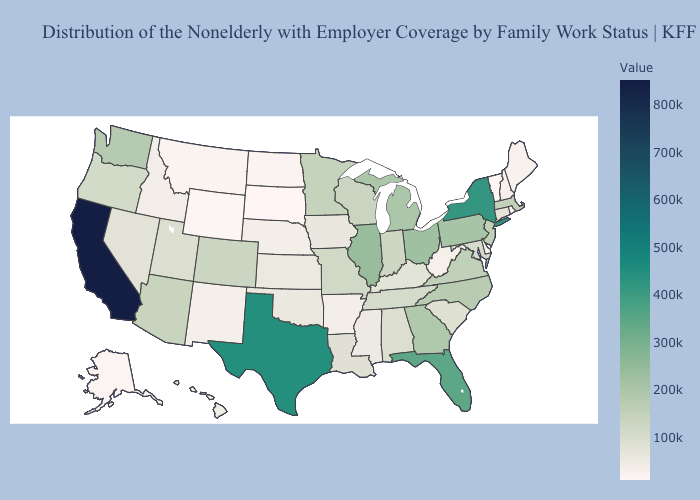Among the states that border Mississippi , does Louisiana have the lowest value?
Answer briefly. No. Does Kentucky have the highest value in the USA?
Write a very short answer. No. Among the states that border Ohio , does West Virginia have the lowest value?
Quick response, please. Yes. Which states hav the highest value in the South?
Concise answer only. Texas. Does Wyoming have the lowest value in the USA?
Short answer required. No. Among the states that border Illinois , does Indiana have the highest value?
Short answer required. No. 